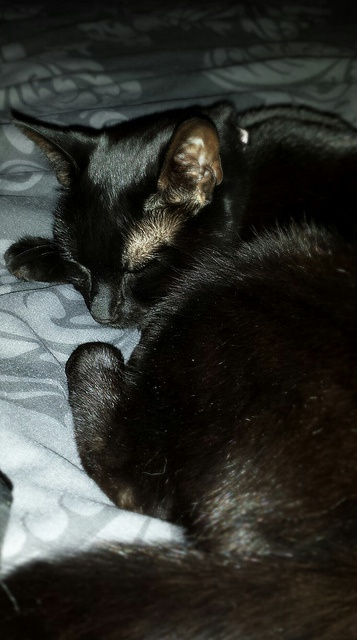Describe the objects in this image and their specific colors. I can see cat in black, gray, and darkgray tones and bed in black, lightgray, gray, and darkgray tones in this image. 